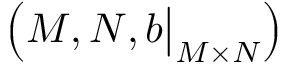<formula> <loc_0><loc_0><loc_500><loc_500>\left ( M , N , b { \Big | } _ { M \times N } \right )</formula> 